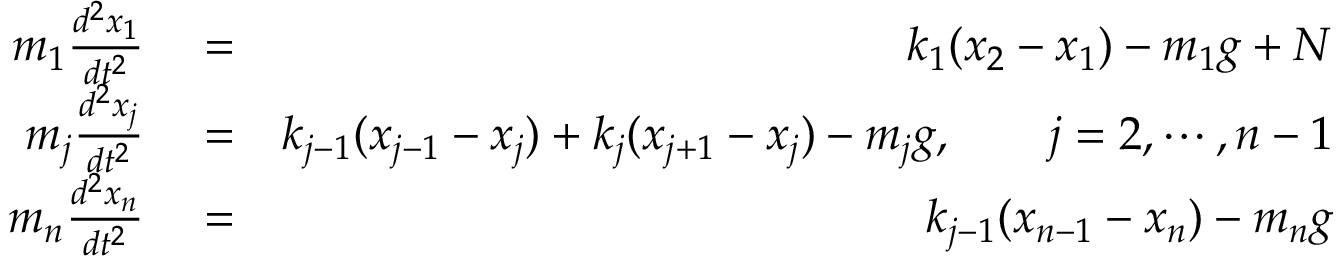Convert formula to latex. <formula><loc_0><loc_0><loc_500><loc_500>\begin{array} { r l r } { m _ { 1 } \frac { d ^ { 2 } x _ { 1 } } { d t ^ { 2 } } } & = } & { k _ { 1 } ( x _ { 2 } - x _ { 1 } ) - m _ { 1 } g + N } \\ { m _ { j } \frac { d ^ { 2 } x _ { j } } { d t ^ { 2 } } } & = } & { k _ { j - 1 } ( x _ { j - 1 } - x _ { j } ) + k _ { j } ( x _ { j + 1 } - x _ { j } ) - m _ { j } g , \quad j = 2 , \cdots , n - 1 } \\ { m _ { n } \frac { d ^ { 2 } x _ { n } } { d t ^ { 2 } } } & = } & { k _ { j - 1 } ( x _ { n - 1 } - x _ { n } ) - m _ { n } g } \end{array}</formula> 